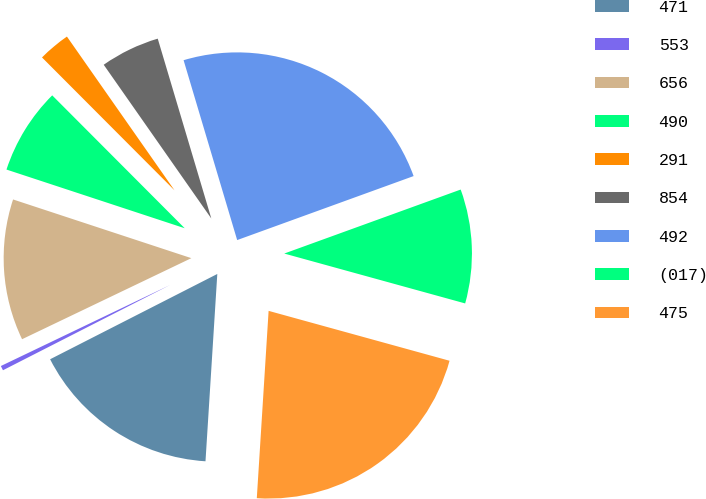Convert chart. <chart><loc_0><loc_0><loc_500><loc_500><pie_chart><fcel>471<fcel>553<fcel>656<fcel>490<fcel>291<fcel>854<fcel>492<fcel>(017)<fcel>475<nl><fcel>16.49%<fcel>0.4%<fcel>12.17%<fcel>7.46%<fcel>2.76%<fcel>5.11%<fcel>24.07%<fcel>9.82%<fcel>21.72%<nl></chart> 